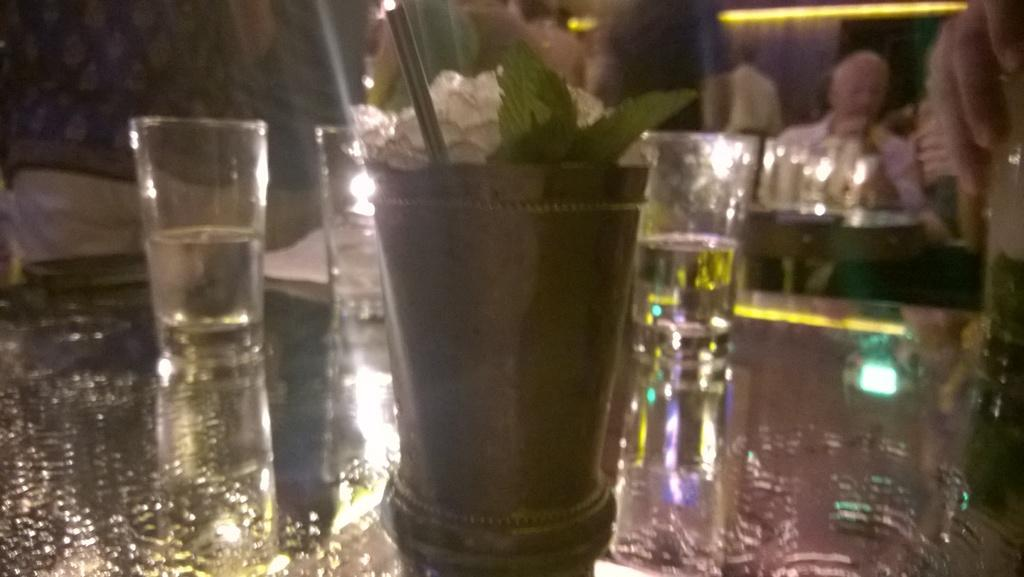What objects are in the center of the image? The glasses are in the center of the image. Where are the glasses located? The glasses are placed on a table. What type of camera is being used to take a picture of the glasses in the image? There is no camera present in the image; it only shows glasses placed on a table. What topic is being discussed by the glasses in the image? Glasses are inanimate objects and cannot engage in discussions. 